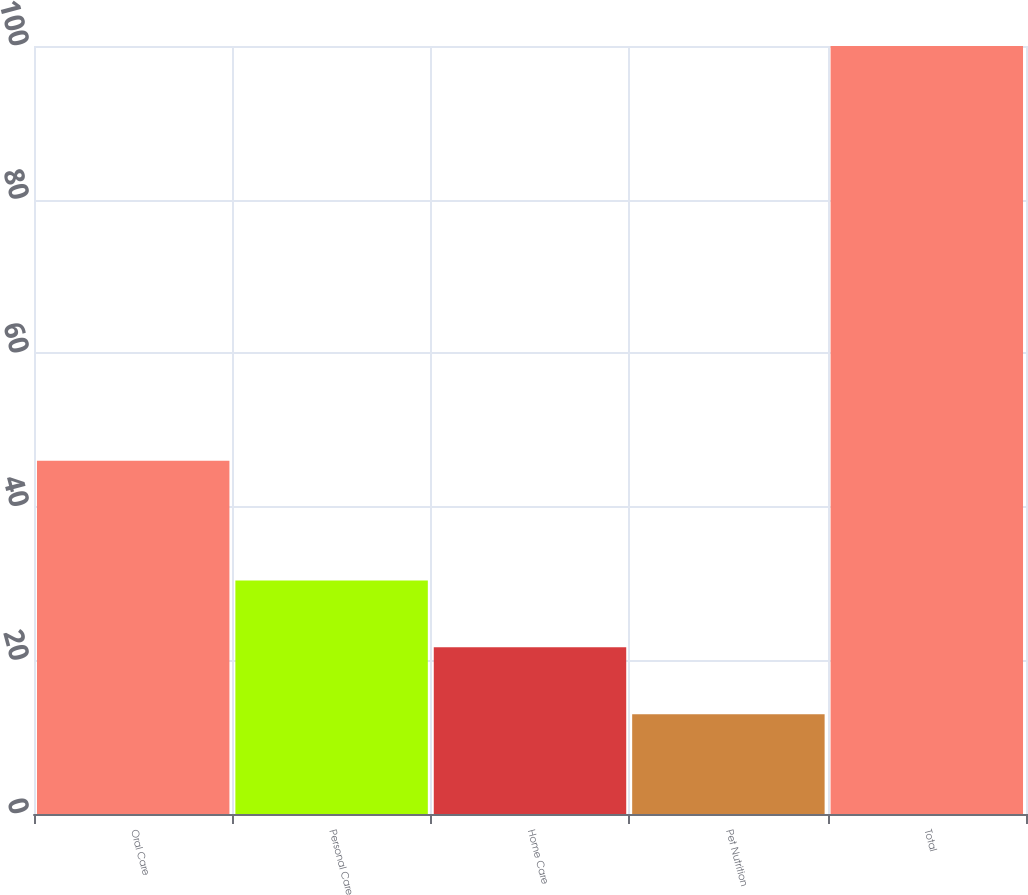Convert chart. <chart><loc_0><loc_0><loc_500><loc_500><bar_chart><fcel>Oral Care<fcel>Personal Care<fcel>Home Care<fcel>Pet Nutrition<fcel>Total<nl><fcel>46<fcel>30.4<fcel>21.7<fcel>13<fcel>100<nl></chart> 